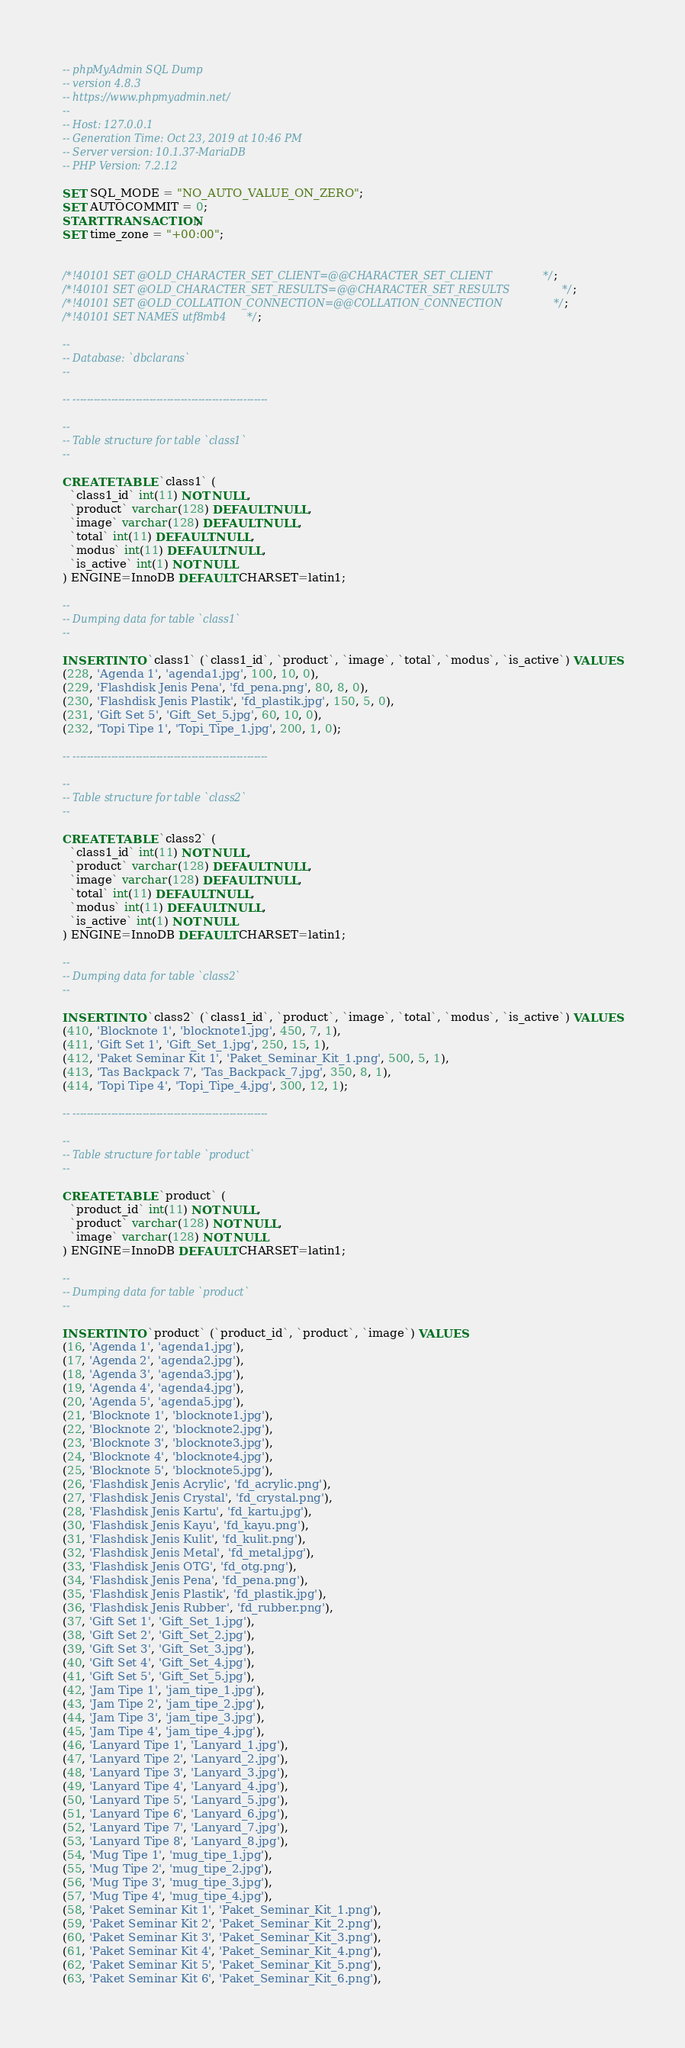<code> <loc_0><loc_0><loc_500><loc_500><_SQL_>-- phpMyAdmin SQL Dump
-- version 4.8.3
-- https://www.phpmyadmin.net/
--
-- Host: 127.0.0.1
-- Generation Time: Oct 23, 2019 at 10:46 PM
-- Server version: 10.1.37-MariaDB
-- PHP Version: 7.2.12

SET SQL_MODE = "NO_AUTO_VALUE_ON_ZERO";
SET AUTOCOMMIT = 0;
START TRANSACTION;
SET time_zone = "+00:00";


/*!40101 SET @OLD_CHARACTER_SET_CLIENT=@@CHARACTER_SET_CLIENT */;
/*!40101 SET @OLD_CHARACTER_SET_RESULTS=@@CHARACTER_SET_RESULTS */;
/*!40101 SET @OLD_COLLATION_CONNECTION=@@COLLATION_CONNECTION */;
/*!40101 SET NAMES utf8mb4 */;

--
-- Database: `dbclarans`
--

-- --------------------------------------------------------

--
-- Table structure for table `class1`
--

CREATE TABLE `class1` (
  `class1_id` int(11) NOT NULL,
  `product` varchar(128) DEFAULT NULL,
  `image` varchar(128) DEFAULT NULL,
  `total` int(11) DEFAULT NULL,
  `modus` int(11) DEFAULT NULL,
  `is_active` int(1) NOT NULL
) ENGINE=InnoDB DEFAULT CHARSET=latin1;

--
-- Dumping data for table `class1`
--

INSERT INTO `class1` (`class1_id`, `product`, `image`, `total`, `modus`, `is_active`) VALUES
(228, 'Agenda 1', 'agenda1.jpg', 100, 10, 0),
(229, 'Flashdisk Jenis Pena', 'fd_pena.png', 80, 8, 0),
(230, 'Flashdisk Jenis Plastik', 'fd_plastik.jpg', 150, 5, 0),
(231, 'Gift Set 5', 'Gift_Set_5.jpg', 60, 10, 0),
(232, 'Topi Tipe 1', 'Topi_Tipe_1.jpg', 200, 1, 0);

-- --------------------------------------------------------

--
-- Table structure for table `class2`
--

CREATE TABLE `class2` (
  `class1_id` int(11) NOT NULL,
  `product` varchar(128) DEFAULT NULL,
  `image` varchar(128) DEFAULT NULL,
  `total` int(11) DEFAULT NULL,
  `modus` int(11) DEFAULT NULL,
  `is_active` int(1) NOT NULL
) ENGINE=InnoDB DEFAULT CHARSET=latin1;

--
-- Dumping data for table `class2`
--

INSERT INTO `class2` (`class1_id`, `product`, `image`, `total`, `modus`, `is_active`) VALUES
(410, 'Blocknote 1', 'blocknote1.jpg', 450, 7, 1),
(411, 'Gift Set 1', 'Gift_Set_1.jpg', 250, 15, 1),
(412, 'Paket Seminar Kit 1', 'Paket_Seminar_Kit_1.png', 500, 5, 1),
(413, 'Tas Backpack 7', 'Tas_Backpack_7.jpg', 350, 8, 1),
(414, 'Topi Tipe 4', 'Topi_Tipe_4.jpg', 300, 12, 1);

-- --------------------------------------------------------

--
-- Table structure for table `product`
--

CREATE TABLE `product` (
  `product_id` int(11) NOT NULL,
  `product` varchar(128) NOT NULL,
  `image` varchar(128) NOT NULL
) ENGINE=InnoDB DEFAULT CHARSET=latin1;

--
-- Dumping data for table `product`
--

INSERT INTO `product` (`product_id`, `product`, `image`) VALUES
(16, 'Agenda 1', 'agenda1.jpg'),
(17, 'Agenda 2', 'agenda2.jpg'),
(18, 'Agenda 3', 'agenda3.jpg'),
(19, 'Agenda 4', 'agenda4.jpg'),
(20, 'Agenda 5', 'agenda5.jpg'),
(21, 'Blocknote 1', 'blocknote1.jpg'),
(22, 'Blocknote 2', 'blocknote2.jpg'),
(23, 'Blocknote 3', 'blocknote3.jpg'),
(24, 'Blocknote 4', 'blocknote4.jpg'),
(25, 'Blocknote 5', 'blocknote5.jpg'),
(26, 'Flashdisk Jenis Acrylic', 'fd_acrylic.png'),
(27, 'Flashdisk Jenis Crystal', 'fd_crystal.png'),
(28, 'Flashdisk Jenis Kartu', 'fd_kartu.jpg'),
(30, 'Flashdisk Jenis Kayu', 'fd_kayu.png'),
(31, 'Flashdisk Jenis Kulit', 'fd_kulit.png'),
(32, 'Flashdisk Jenis Metal', 'fd_metal.jpg'),
(33, 'Flashdisk Jenis OTG', 'fd_otg.png'),
(34, 'Flashdisk Jenis Pena', 'fd_pena.png'),
(35, 'Flashdisk Jenis Plastik', 'fd_plastik.jpg'),
(36, 'Flashdisk Jenis Rubber', 'fd_rubber.png'),
(37, 'Gift Set 1', 'Gift_Set_1.jpg'),
(38, 'Gift Set 2', 'Gift_Set_2.jpg'),
(39, 'Gift Set 3', 'Gift_Set_3.jpg'),
(40, 'Gift Set 4', 'Gift_Set_4.jpg'),
(41, 'Gift Set 5', 'Gift_Set_5.jpg'),
(42, 'Jam Tipe 1', 'jam_tipe_1.jpg'),
(43, 'Jam Tipe 2', 'jam_tipe_2.jpg'),
(44, 'Jam Tipe 3', 'jam_tipe_3.jpg'),
(45, 'Jam Tipe 4', 'jam_tipe_4.jpg'),
(46, 'Lanyard Tipe 1', 'Lanyard_1.jpg'),
(47, 'Lanyard Tipe 2', 'Lanyard_2.jpg'),
(48, 'Lanyard Tipe 3', 'Lanyard_3.jpg'),
(49, 'Lanyard Tipe 4', 'Lanyard_4.jpg'),
(50, 'Lanyard Tipe 5', 'Lanyard_5.jpg'),
(51, 'Lanyard Tipe 6', 'Lanyard_6.jpg'),
(52, 'Lanyard Tipe 7', 'Lanyard_7.jpg'),
(53, 'Lanyard Tipe 8', 'Lanyard_8.jpg'),
(54, 'Mug Tipe 1', 'mug_tipe_1.jpg'),
(55, 'Mug Tipe 2', 'mug_tipe_2.jpg'),
(56, 'Mug Tipe 3', 'mug_tipe_3.jpg'),
(57, 'Mug Tipe 4', 'mug_tipe_4.jpg'),
(58, 'Paket Seminar Kit 1', 'Paket_Seminar_Kit_1.png'),
(59, 'Paket Seminar Kit 2', 'Paket_Seminar_Kit_2.png'),
(60, 'Paket Seminar Kit 3', 'Paket_Seminar_Kit_3.png'),
(61, 'Paket Seminar Kit 4', 'Paket_Seminar_Kit_4.png'),
(62, 'Paket Seminar Kit 5', 'Paket_Seminar_Kit_5.png'),
(63, 'Paket Seminar Kit 6', 'Paket_Seminar_Kit_6.png'),</code> 